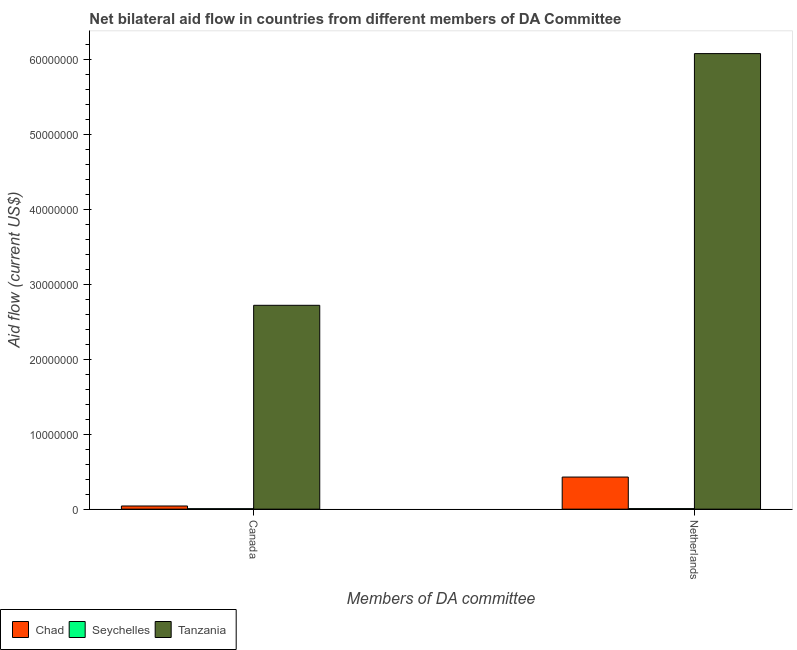What is the label of the 1st group of bars from the left?
Make the answer very short. Canada. What is the amount of aid given by canada in Seychelles?
Make the answer very short. 6.00e+04. Across all countries, what is the maximum amount of aid given by canada?
Offer a terse response. 2.72e+07. Across all countries, what is the minimum amount of aid given by netherlands?
Your response must be concise. 7.00e+04. In which country was the amount of aid given by canada maximum?
Make the answer very short. Tanzania. In which country was the amount of aid given by netherlands minimum?
Make the answer very short. Seychelles. What is the total amount of aid given by canada in the graph?
Offer a very short reply. 2.77e+07. What is the difference between the amount of aid given by canada in Tanzania and that in Chad?
Keep it short and to the point. 2.68e+07. What is the difference between the amount of aid given by canada in Seychelles and the amount of aid given by netherlands in Tanzania?
Your answer should be very brief. -6.07e+07. What is the average amount of aid given by netherlands per country?
Offer a terse response. 2.17e+07. What is the difference between the amount of aid given by netherlands and amount of aid given by canada in Tanzania?
Offer a terse response. 3.36e+07. What is the ratio of the amount of aid given by canada in Tanzania to that in Chad?
Give a very brief answer. 64.71. Is the amount of aid given by canada in Tanzania less than that in Seychelles?
Provide a short and direct response. No. In how many countries, is the amount of aid given by netherlands greater than the average amount of aid given by netherlands taken over all countries?
Keep it short and to the point. 1. What does the 1st bar from the left in Canada represents?
Ensure brevity in your answer.  Chad. What does the 2nd bar from the right in Netherlands represents?
Offer a very short reply. Seychelles. Where does the legend appear in the graph?
Offer a very short reply. Bottom left. How many legend labels are there?
Offer a very short reply. 3. How are the legend labels stacked?
Your answer should be compact. Horizontal. What is the title of the graph?
Make the answer very short. Net bilateral aid flow in countries from different members of DA Committee. Does "Fragile and conflict affected situations" appear as one of the legend labels in the graph?
Your answer should be compact. No. What is the label or title of the X-axis?
Your response must be concise. Members of DA committee. What is the label or title of the Y-axis?
Your answer should be very brief. Aid flow (current US$). What is the Aid flow (current US$) in Tanzania in Canada?
Ensure brevity in your answer.  2.72e+07. What is the Aid flow (current US$) of Chad in Netherlands?
Your response must be concise. 4.28e+06. What is the Aid flow (current US$) in Seychelles in Netherlands?
Give a very brief answer. 7.00e+04. What is the Aid flow (current US$) in Tanzania in Netherlands?
Give a very brief answer. 6.07e+07. Across all Members of DA committee, what is the maximum Aid flow (current US$) of Chad?
Your response must be concise. 4.28e+06. Across all Members of DA committee, what is the maximum Aid flow (current US$) of Seychelles?
Provide a short and direct response. 7.00e+04. Across all Members of DA committee, what is the maximum Aid flow (current US$) in Tanzania?
Your answer should be very brief. 6.07e+07. Across all Members of DA committee, what is the minimum Aid flow (current US$) of Tanzania?
Offer a very short reply. 2.72e+07. What is the total Aid flow (current US$) in Chad in the graph?
Your answer should be very brief. 4.70e+06. What is the total Aid flow (current US$) of Seychelles in the graph?
Your answer should be compact. 1.30e+05. What is the total Aid flow (current US$) of Tanzania in the graph?
Your response must be concise. 8.79e+07. What is the difference between the Aid flow (current US$) in Chad in Canada and that in Netherlands?
Offer a terse response. -3.86e+06. What is the difference between the Aid flow (current US$) in Seychelles in Canada and that in Netherlands?
Ensure brevity in your answer.  -10000. What is the difference between the Aid flow (current US$) of Tanzania in Canada and that in Netherlands?
Make the answer very short. -3.36e+07. What is the difference between the Aid flow (current US$) in Chad in Canada and the Aid flow (current US$) in Seychelles in Netherlands?
Offer a terse response. 3.50e+05. What is the difference between the Aid flow (current US$) in Chad in Canada and the Aid flow (current US$) in Tanzania in Netherlands?
Provide a succinct answer. -6.03e+07. What is the difference between the Aid flow (current US$) of Seychelles in Canada and the Aid flow (current US$) of Tanzania in Netherlands?
Keep it short and to the point. -6.07e+07. What is the average Aid flow (current US$) in Chad per Members of DA committee?
Keep it short and to the point. 2.35e+06. What is the average Aid flow (current US$) in Seychelles per Members of DA committee?
Provide a succinct answer. 6.50e+04. What is the average Aid flow (current US$) in Tanzania per Members of DA committee?
Give a very brief answer. 4.40e+07. What is the difference between the Aid flow (current US$) in Chad and Aid flow (current US$) in Seychelles in Canada?
Give a very brief answer. 3.60e+05. What is the difference between the Aid flow (current US$) in Chad and Aid flow (current US$) in Tanzania in Canada?
Offer a terse response. -2.68e+07. What is the difference between the Aid flow (current US$) of Seychelles and Aid flow (current US$) of Tanzania in Canada?
Make the answer very short. -2.71e+07. What is the difference between the Aid flow (current US$) in Chad and Aid flow (current US$) in Seychelles in Netherlands?
Provide a succinct answer. 4.21e+06. What is the difference between the Aid flow (current US$) in Chad and Aid flow (current US$) in Tanzania in Netherlands?
Your response must be concise. -5.65e+07. What is the difference between the Aid flow (current US$) of Seychelles and Aid flow (current US$) of Tanzania in Netherlands?
Your answer should be very brief. -6.07e+07. What is the ratio of the Aid flow (current US$) in Chad in Canada to that in Netherlands?
Give a very brief answer. 0.1. What is the ratio of the Aid flow (current US$) of Seychelles in Canada to that in Netherlands?
Your answer should be very brief. 0.86. What is the ratio of the Aid flow (current US$) of Tanzania in Canada to that in Netherlands?
Your answer should be very brief. 0.45. What is the difference between the highest and the second highest Aid flow (current US$) of Chad?
Your answer should be very brief. 3.86e+06. What is the difference between the highest and the second highest Aid flow (current US$) of Tanzania?
Your answer should be very brief. 3.36e+07. What is the difference between the highest and the lowest Aid flow (current US$) in Chad?
Your response must be concise. 3.86e+06. What is the difference between the highest and the lowest Aid flow (current US$) of Seychelles?
Your answer should be very brief. 10000. What is the difference between the highest and the lowest Aid flow (current US$) in Tanzania?
Keep it short and to the point. 3.36e+07. 